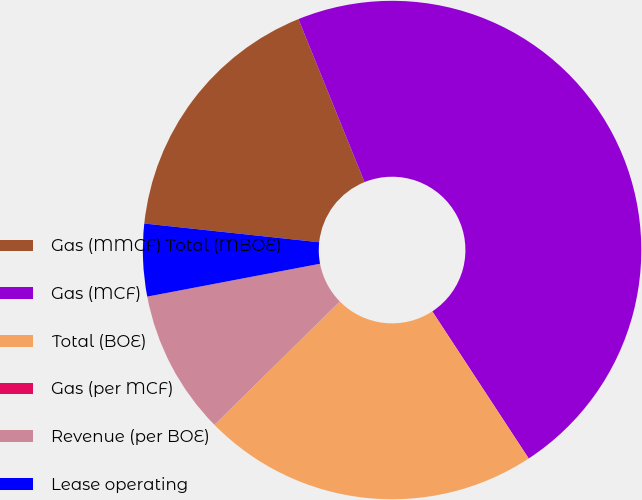Convert chart. <chart><loc_0><loc_0><loc_500><loc_500><pie_chart><fcel>Gas (MMCF) Total (MBOE)<fcel>Gas (MCF)<fcel>Total (BOE)<fcel>Gas (per MCF)<fcel>Revenue (per BOE)<fcel>Lease operating<nl><fcel>17.17%<fcel>46.9%<fcel>21.86%<fcel>0.0%<fcel>9.38%<fcel>4.69%<nl></chart> 